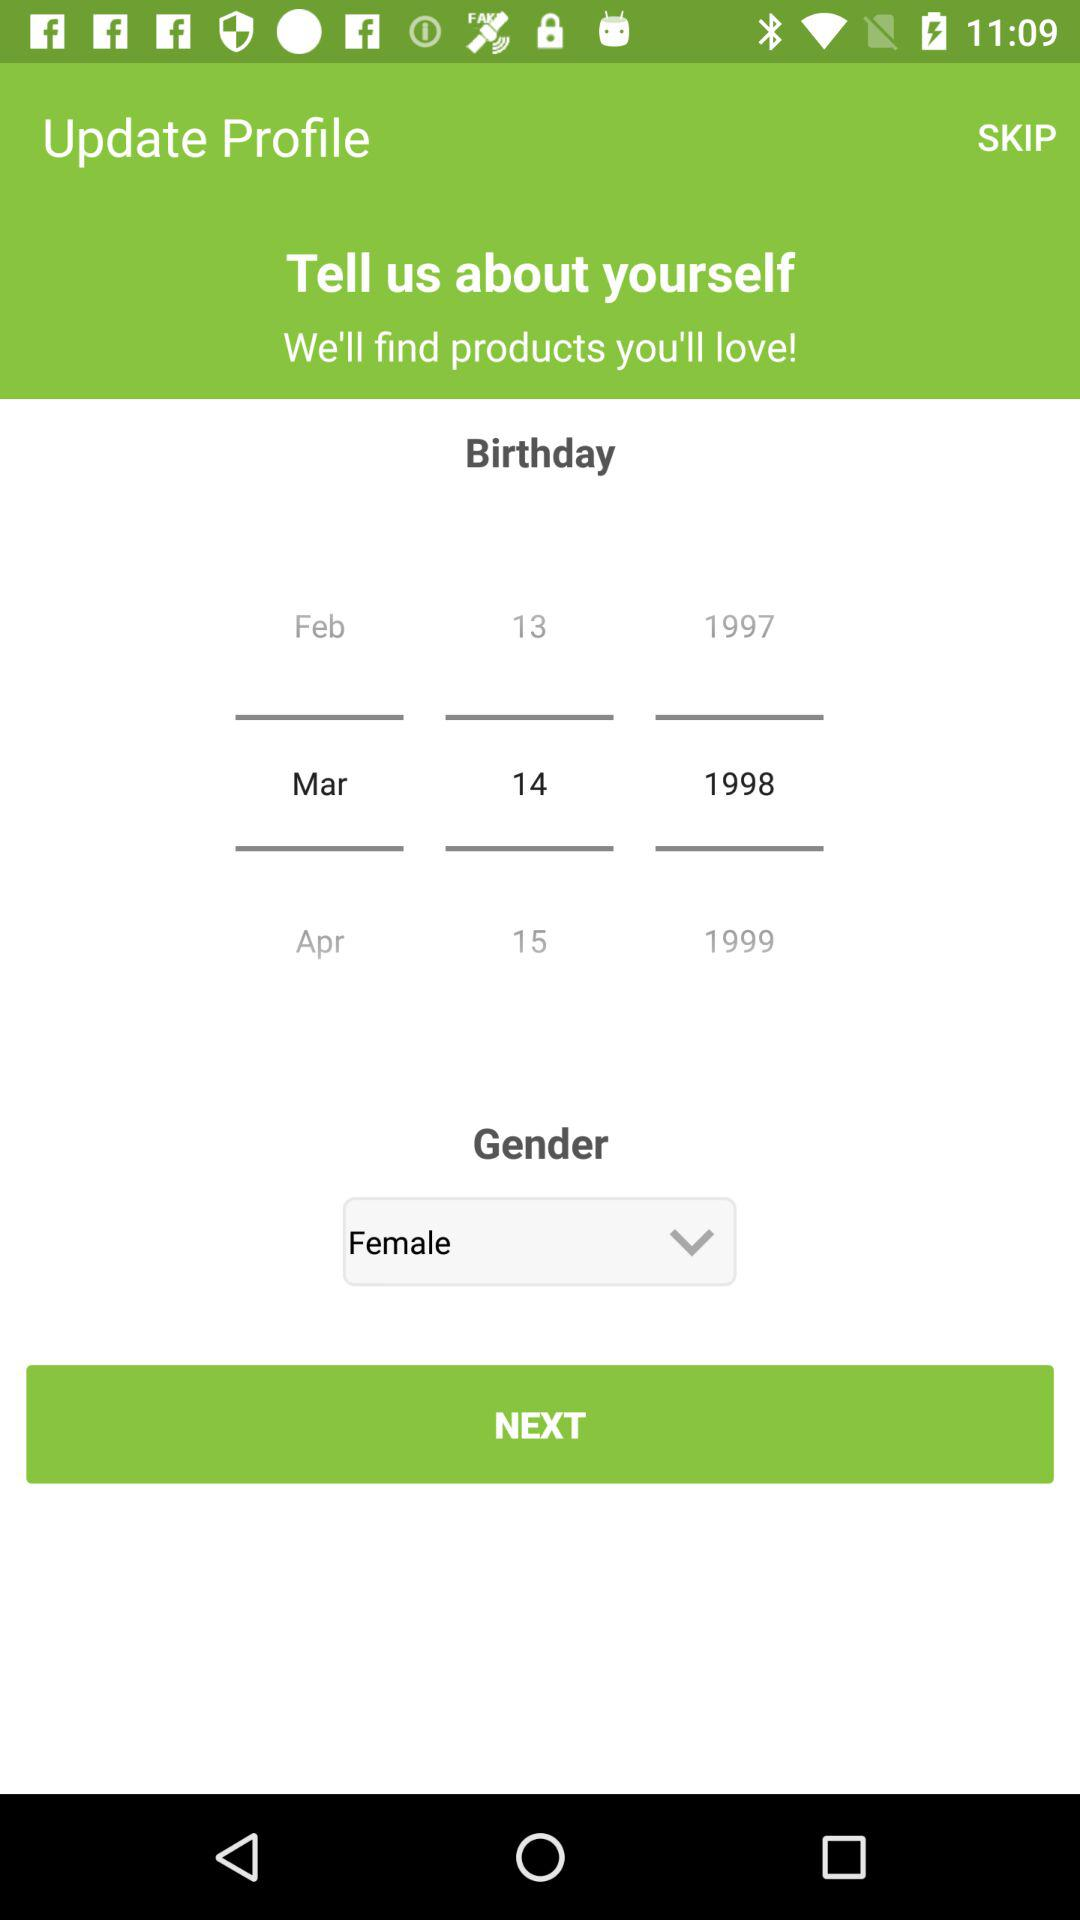How many years older is the person who was born in 1998 than the person who was born in 1999?
Answer the question using a single word or phrase. 1 